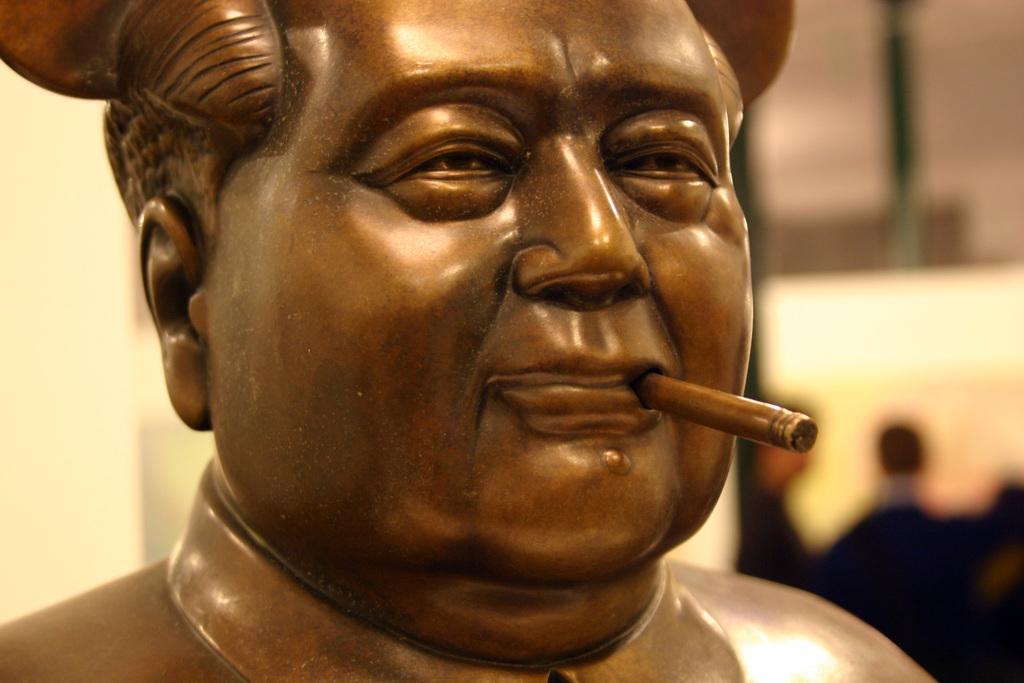In one or two sentences, can you explain what this image depicts? In this image we can see a sculpture, and the background is blurred. 